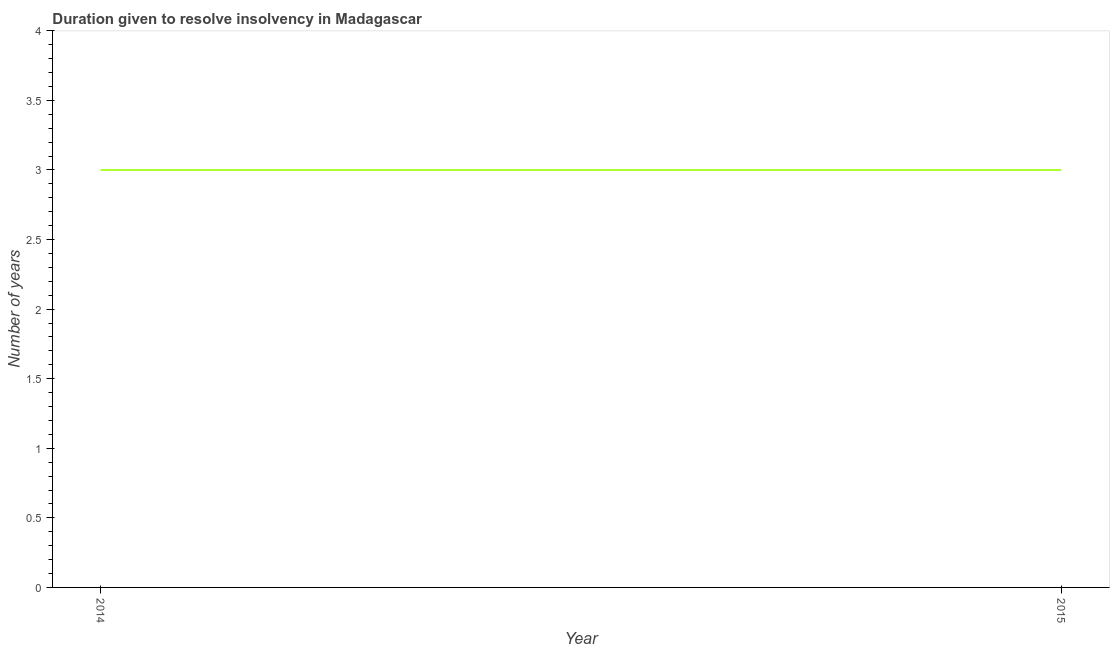What is the number of years to resolve insolvency in 2014?
Provide a short and direct response. 3. Across all years, what is the maximum number of years to resolve insolvency?
Ensure brevity in your answer.  3. Across all years, what is the minimum number of years to resolve insolvency?
Provide a succinct answer. 3. In which year was the number of years to resolve insolvency maximum?
Your answer should be compact. 2014. In which year was the number of years to resolve insolvency minimum?
Keep it short and to the point. 2014. What is the sum of the number of years to resolve insolvency?
Provide a short and direct response. 6. What is the median number of years to resolve insolvency?
Keep it short and to the point. 3. Do a majority of the years between 2015 and 2014 (inclusive) have number of years to resolve insolvency greater than 3 ?
Ensure brevity in your answer.  No. What is the ratio of the number of years to resolve insolvency in 2014 to that in 2015?
Offer a terse response. 1. Is the number of years to resolve insolvency in 2014 less than that in 2015?
Offer a terse response. No. In how many years, is the number of years to resolve insolvency greater than the average number of years to resolve insolvency taken over all years?
Make the answer very short. 0. Does the number of years to resolve insolvency monotonically increase over the years?
Keep it short and to the point. No. What is the difference between two consecutive major ticks on the Y-axis?
Give a very brief answer. 0.5. Are the values on the major ticks of Y-axis written in scientific E-notation?
Your answer should be compact. No. What is the title of the graph?
Offer a very short reply. Duration given to resolve insolvency in Madagascar. What is the label or title of the X-axis?
Offer a very short reply. Year. What is the label or title of the Y-axis?
Provide a short and direct response. Number of years. What is the Number of years of 2014?
Your answer should be very brief. 3. What is the difference between the Number of years in 2014 and 2015?
Offer a terse response. 0. 